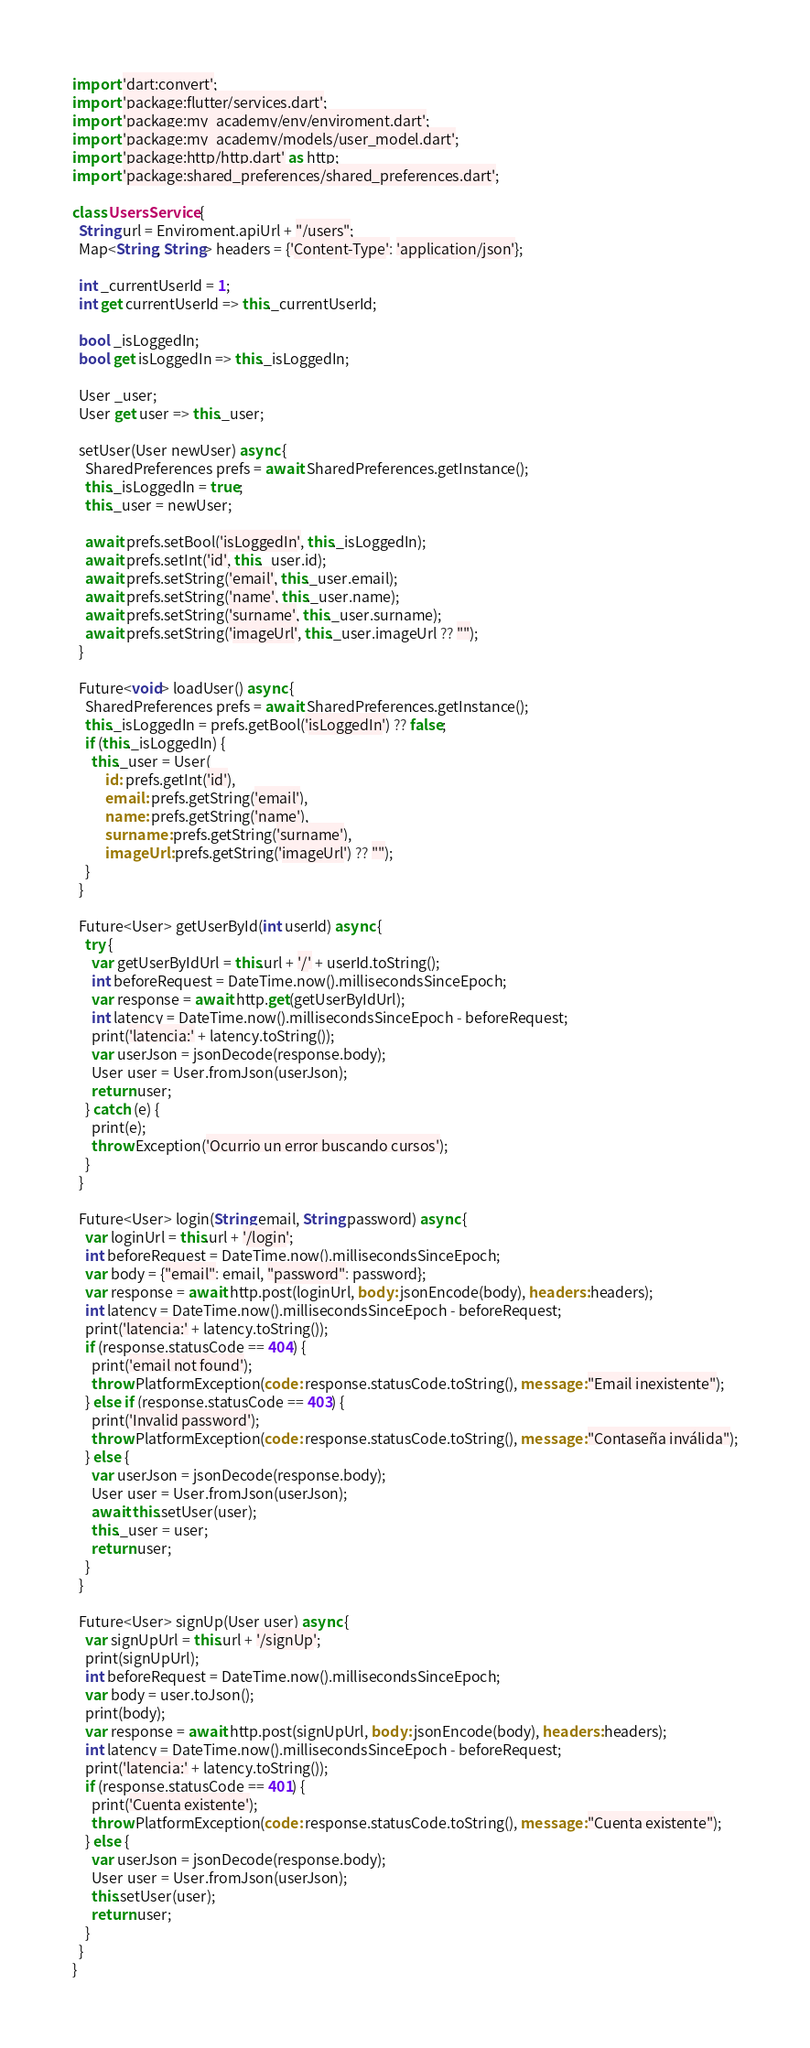Convert code to text. <code><loc_0><loc_0><loc_500><loc_500><_Dart_>import 'dart:convert';
import 'package:flutter/services.dart';
import 'package:my_academy/env/enviroment.dart';
import 'package:my_academy/models/user_model.dart';
import 'package:http/http.dart' as http;
import 'package:shared_preferences/shared_preferences.dart';

class UsersService {
  String url = Enviroment.apiUrl + "/users";
  Map<String, String> headers = {'Content-Type': 'application/json'};

  int _currentUserId = 1;
  int get currentUserId => this._currentUserId;

  bool _isLoggedIn;
  bool get isLoggedIn => this._isLoggedIn;

  User _user;
  User get user => this._user;

  setUser(User newUser) async {
    SharedPreferences prefs = await SharedPreferences.getInstance();
    this._isLoggedIn = true;
    this._user = newUser;

    await prefs.setBool('isLoggedIn', this._isLoggedIn);
    await prefs.setInt('id', this._user.id);
    await prefs.setString('email', this._user.email);
    await prefs.setString('name', this._user.name);
    await prefs.setString('surname', this._user.surname);
    await prefs.setString('imageUrl', this._user.imageUrl ?? "");
  }

  Future<void> loadUser() async {
    SharedPreferences prefs = await SharedPreferences.getInstance();
    this._isLoggedIn = prefs.getBool('isLoggedIn') ?? false;
    if (this._isLoggedIn) {
      this._user = User(
          id: prefs.getInt('id'),
          email: prefs.getString('email'),
          name: prefs.getString('name'),
          surname: prefs.getString('surname'),
          imageUrl: prefs.getString('imageUrl') ?? "");
    }
  }

  Future<User> getUserById(int userId) async {
    try {
      var getUserByIdUrl = this.url + '/' + userId.toString();
      int beforeRequest = DateTime.now().millisecondsSinceEpoch;
      var response = await http.get(getUserByIdUrl);
      int latency = DateTime.now().millisecondsSinceEpoch - beforeRequest;
      print('latencia:' + latency.toString());
      var userJson = jsonDecode(response.body);
      User user = User.fromJson(userJson);
      return user;
    } catch (e) {
      print(e);
      throw Exception('Ocurrio un error buscando cursos');
    }
  }

  Future<User> login(String email, String password) async {
    var loginUrl = this.url + '/login';
    int beforeRequest = DateTime.now().millisecondsSinceEpoch;
    var body = {"email": email, "password": password};
    var response = await http.post(loginUrl, body: jsonEncode(body), headers: headers);
    int latency = DateTime.now().millisecondsSinceEpoch - beforeRequest;
    print('latencia:' + latency.toString());
    if (response.statusCode == 404) {
      print('email not found');
      throw PlatformException(code: response.statusCode.toString(), message: "Email inexistente");
    } else if (response.statusCode == 403) {
      print('Invalid password');
      throw PlatformException(code: response.statusCode.toString(), message: "Contaseña inválida");
    } else {
      var userJson = jsonDecode(response.body);
      User user = User.fromJson(userJson);
      await this.setUser(user);
      this._user = user;
      return user;
    }
  }

  Future<User> signUp(User user) async {
    var signUpUrl = this.url + '/signUp';
    print(signUpUrl);
    int beforeRequest = DateTime.now().millisecondsSinceEpoch;
    var body = user.toJson();
    print(body);
    var response = await http.post(signUpUrl, body: jsonEncode(body), headers: headers);
    int latency = DateTime.now().millisecondsSinceEpoch - beforeRequest;
    print('latencia:' + latency.toString());
    if (response.statusCode == 401) {
      print('Cuenta existente');
      throw PlatformException(code: response.statusCode.toString(), message: "Cuenta existente");
    } else {
      var userJson = jsonDecode(response.body);
      User user = User.fromJson(userJson);
      this.setUser(user);
      return user;
    }
  }
}
</code> 